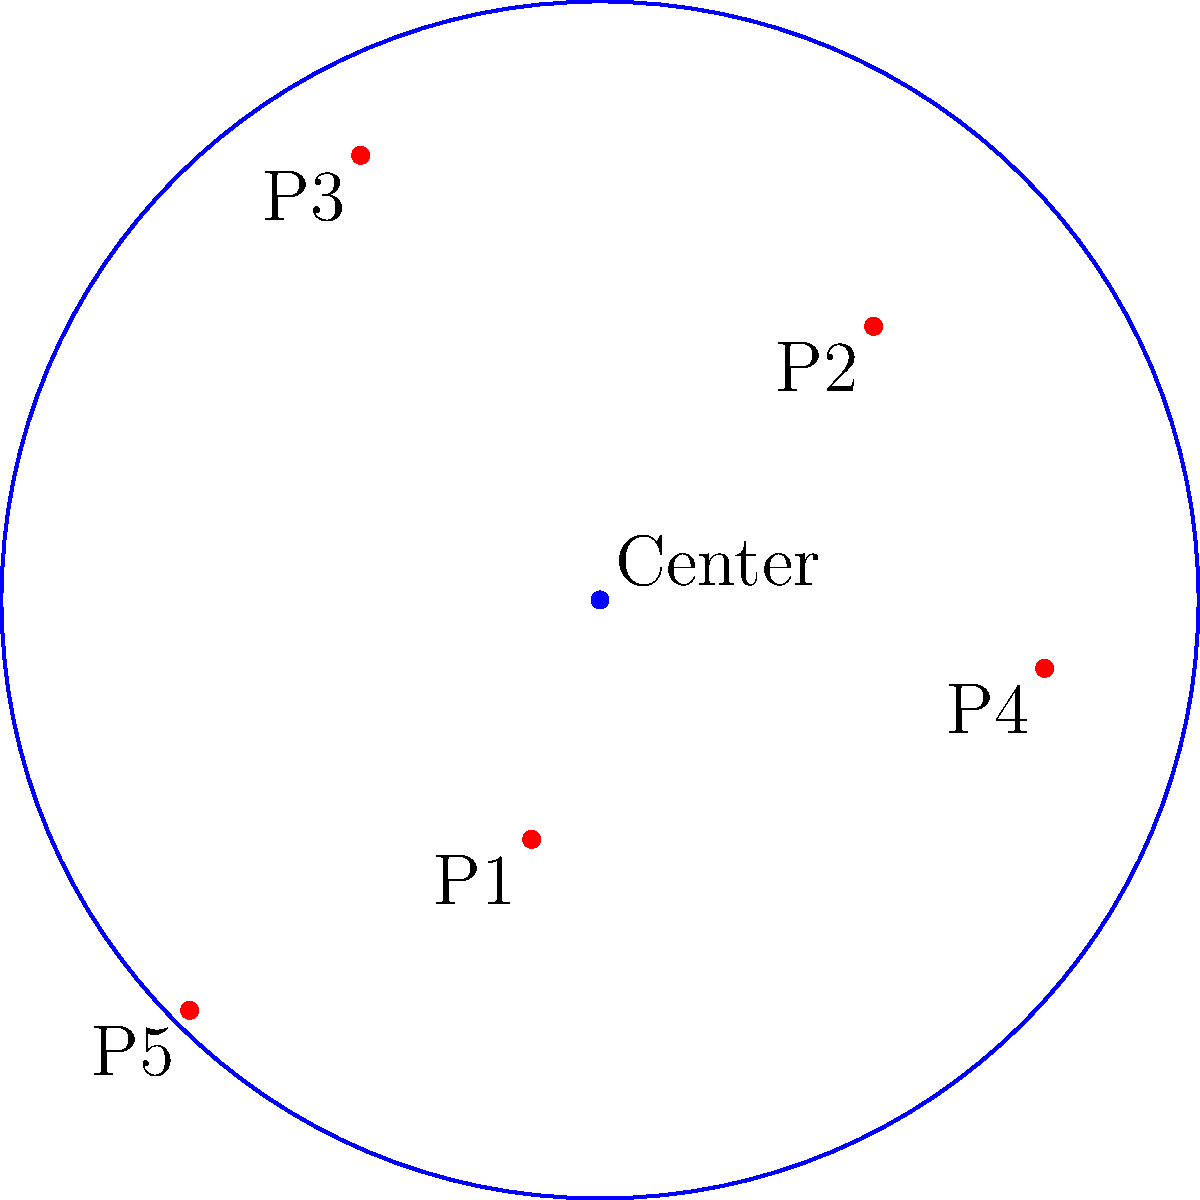In your online community for cyberbullying victims, you want to find the central point that best represents the core of your supportive network. Given the scattered points $P_1(0,0)$, $P_2(2,3)$, $P_3(-1,4)$, $P_4(3,1)$, and $P_5(-2,-1)$ representing different members' positions in a 2D space based on their experiences, find the coordinates of the center point of the smallest circle that encompasses all these points. To find the center of the smallest circle that encompasses all given points (also known as the minimum enclosing circle), we can follow these steps:

1) First, we need to identify the points that lie on the circumference of this circle. In this case, we can see that points $P_2(2,3)$, $P_3(-1,4)$, and $P_5(-2,-1)$ form a triangle that encompasses all other points.

2) The center of the minimum enclosing circle will be equidistant from these three points and will lie at the intersection of the perpendicular bisectors of the sides of this triangle.

3) Let's calculate the midpoints of the sides of this triangle:
   - Midpoint of $P_2P_3$: $(\frac{2+(-1)}{2}, \frac{3+4}{2}) = (0.5, 3.5)$
   - Midpoint of $P_3P_5$: $(\frac{-1+(-2)}{2}, \frac{4+(-1)}{2}) = (-1.5, 1.5)$
   - Midpoint of $P_5P_2$: $(\frac{-2+2}{2}, \frac{-1+3}{2}) = (0, 1)$

4) Now, we need to find the equations of the perpendicular bisectors:
   - For $P_2P_3$: $x - 0.5 = -\frac{1}{3}(y - 3.5)$
   - For $P_3P_5$: $y - 1.5 = \frac{5}{3}(x + 1.5)$

5) Solving these equations simultaneously:
   $x - 0.5 = -\frac{1}{3}(y - 3.5)$
   $y - 1.5 = \frac{5}{3}(x + 1.5)$

   After substitution and simplification, we get:
   $x \approx 0.4$ and $y \approx 1.4$

Therefore, the center of the minimum enclosing circle is approximately at (0.4, 1.4).
Answer: (0.4, 1.4) 